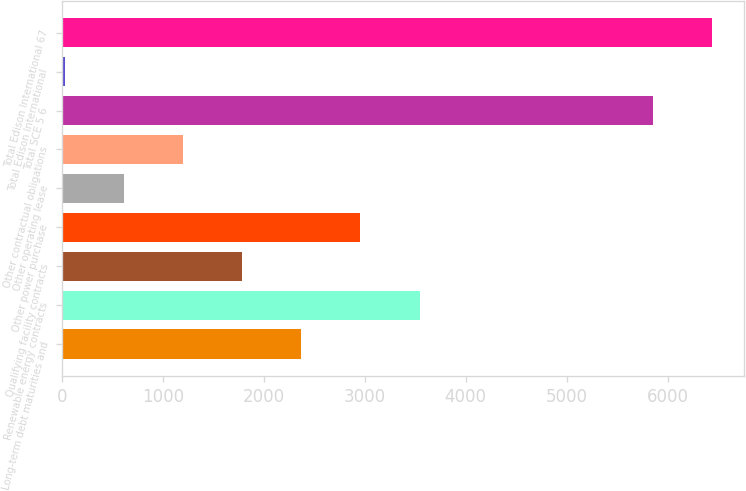<chart> <loc_0><loc_0><loc_500><loc_500><bar_chart><fcel>Long-term debt maturities and<fcel>Renewable energy contracts<fcel>Qualifying facility contracts<fcel>Other power purchase<fcel>Other operating lease<fcel>Other contractual obligations<fcel>Total SCE 5 6<fcel>Total Edison International<fcel>Total Edison International 67<nl><fcel>2372.2<fcel>3542.8<fcel>1786.9<fcel>2957.5<fcel>616.3<fcel>1201.6<fcel>5853<fcel>31<fcel>6438.3<nl></chart> 